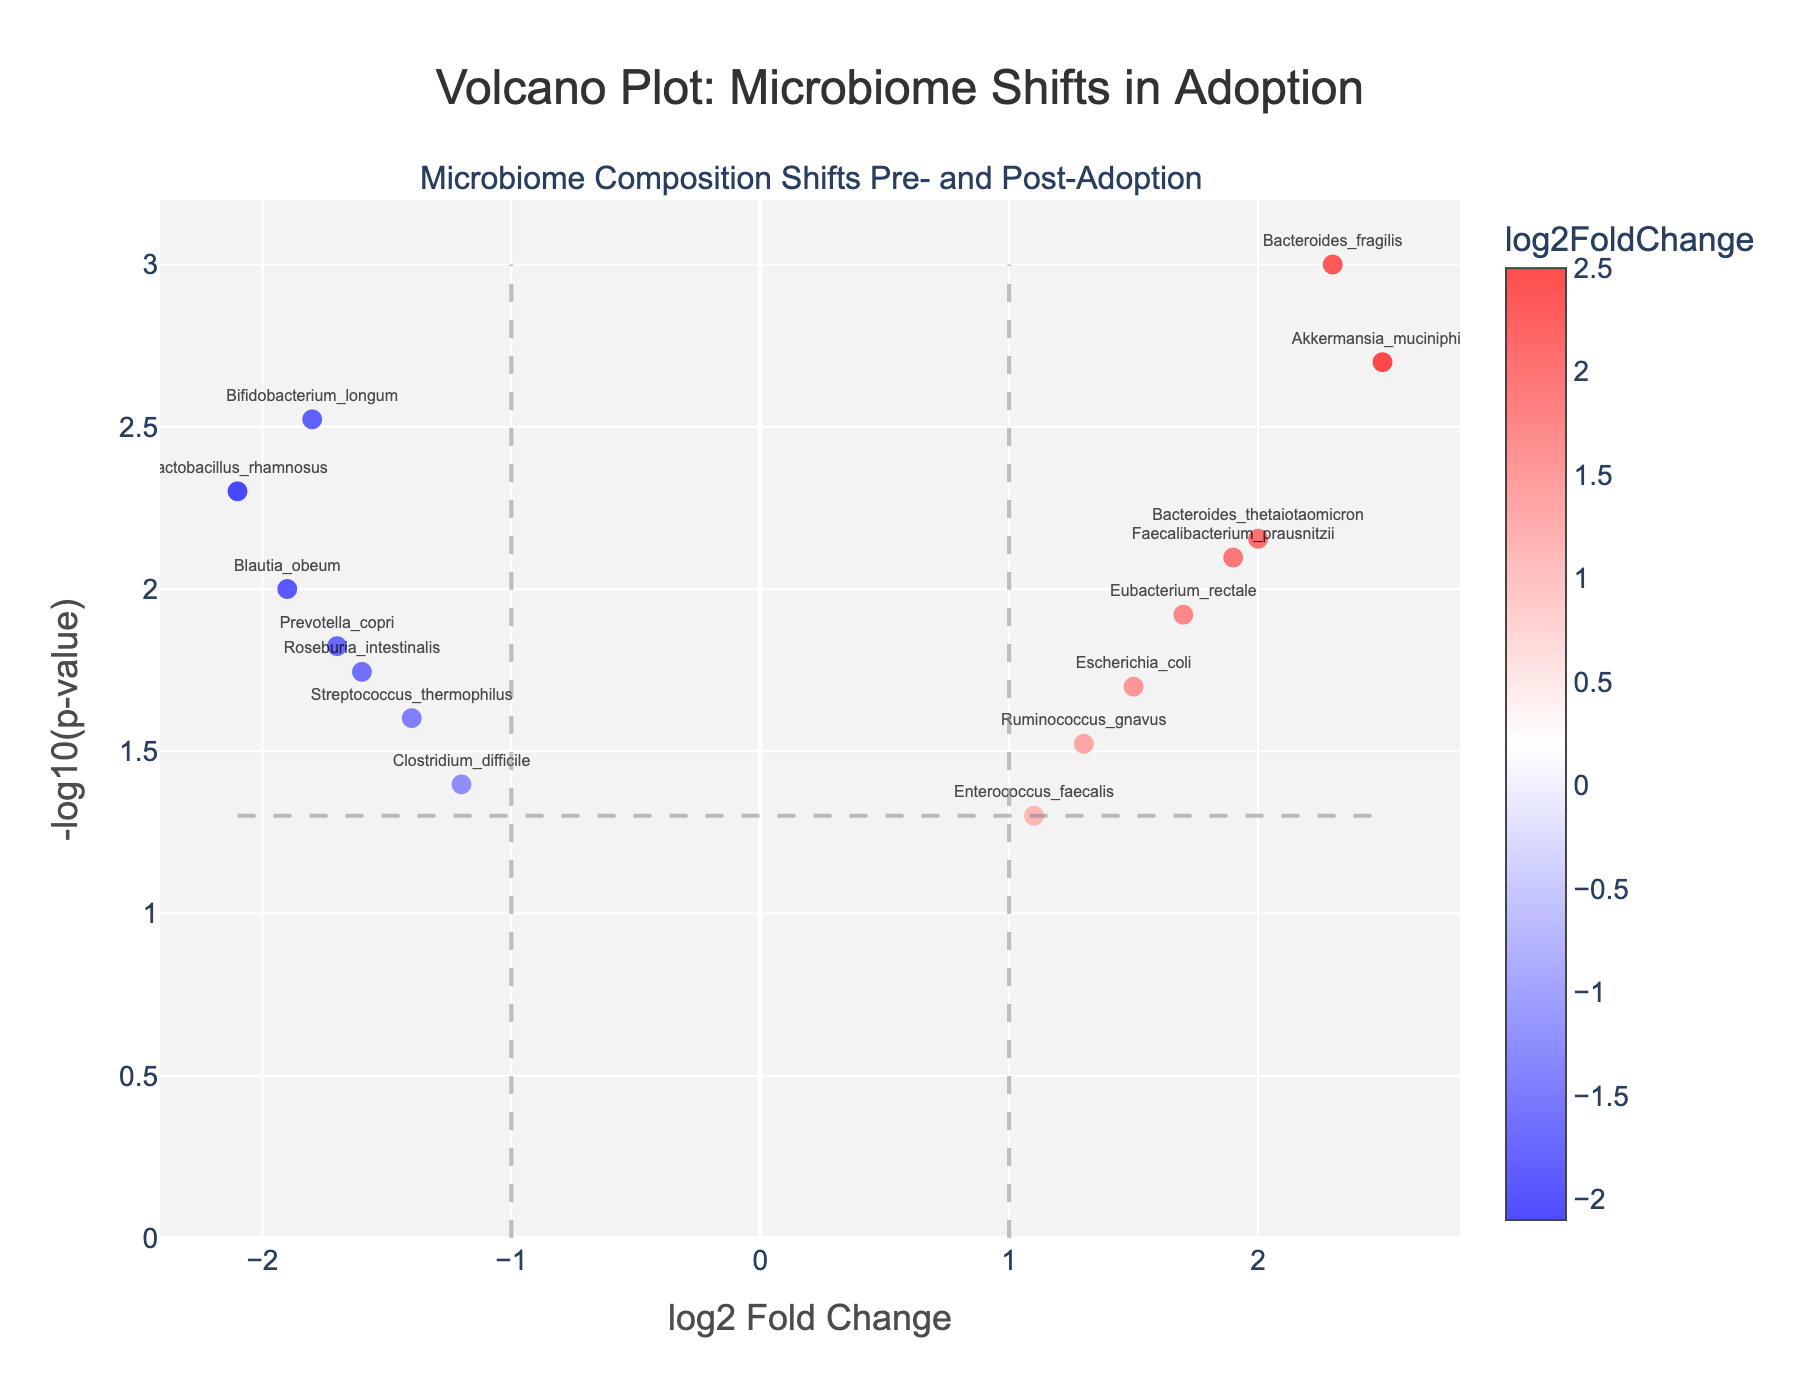What is the title of the plot? The title of the plot is displayed at the top and reads "Volcano Plot: Microbiome Shifts in Adoption". Titles are usually placed prominently to help identify the plot's main focus.
Answer: Volcano Plot: Microbiome Shifts in Adoption How many genes have a positive log2 fold change? By counting the number of data points on the right side of the y-axis where log2 fold change is positive in the figure, we see there are five genes: Bacteroides_fragilis, Escherichia_coli, Faecalibacterium_prausnitzii, Akkermansia_muciniphila, Bacteroides_thetaiotaomicron, Enterococcus_faecalis, and Eubacterium_rectale.
Answer: 7 Which gene has the highest -log10(p-value)? Locate the data point that is positioned highest on the y-axis of the plot. This point represents the gene with the highest -log10(p-value). From the plot, Akkermansia_muciniphila is at the top.
Answer: Akkermansia_muciniphila How many genes have a -log10(p-value) greater than 2? Identify the gene points positioned above the 2 mark on the y-axis. The genes are Bacteroides_fragilis, Bifidobacterium_longum, Lactobacillus_rhamnosus, Akkermansia_muciniphila, and Blautia_obeum. Count these points.
Answer: 5 Which gene has the largest negative log2 fold change? Locate the data point that is furthest to the left on the x-axis where log2 fold change is negative. That point represents the gene with the largest negative log2 fold change. This gene is Lactobacillus_rhamnosus.
Answer: Lactobacillus_rhamnosus Are there more genes with an increase (positive log2 fold change) or decrease (negative log2 fold change)? Count the number of data points on the positive side and the negative side of the x-axis. There are 7 genes with a positive log2 fold change and 8 genes with a negative log2 fold change. Hence, there are more genes with a decrease.
Answer: decrease Which gene has the smallest -log10(p-value) but still shows a differential expression (log2 fold change different from zero)? Find the gene with the lowest -log10(p-value) that is not zero nor very close to the zero mark on the x-axis (log2 fold change). Enterococcus_faecalis has the smallest -log10(p-value) among the genes that show differential expression.
Answer: Enterococcus_faecalis What is the log2 fold change of Bacteroides_fragilis and is it considered significant when p-value threshold is 0.05? Identify Bacteroides_fragilis on the plot and read its log2 fold change (x-axis value) which is 2.3. Also, check the p-value significance which can be inferred from its position above the horizontal line at -log10(0.05). Its p-value is 0.001, thus it is significant.
Answer: 2.3 and significant 